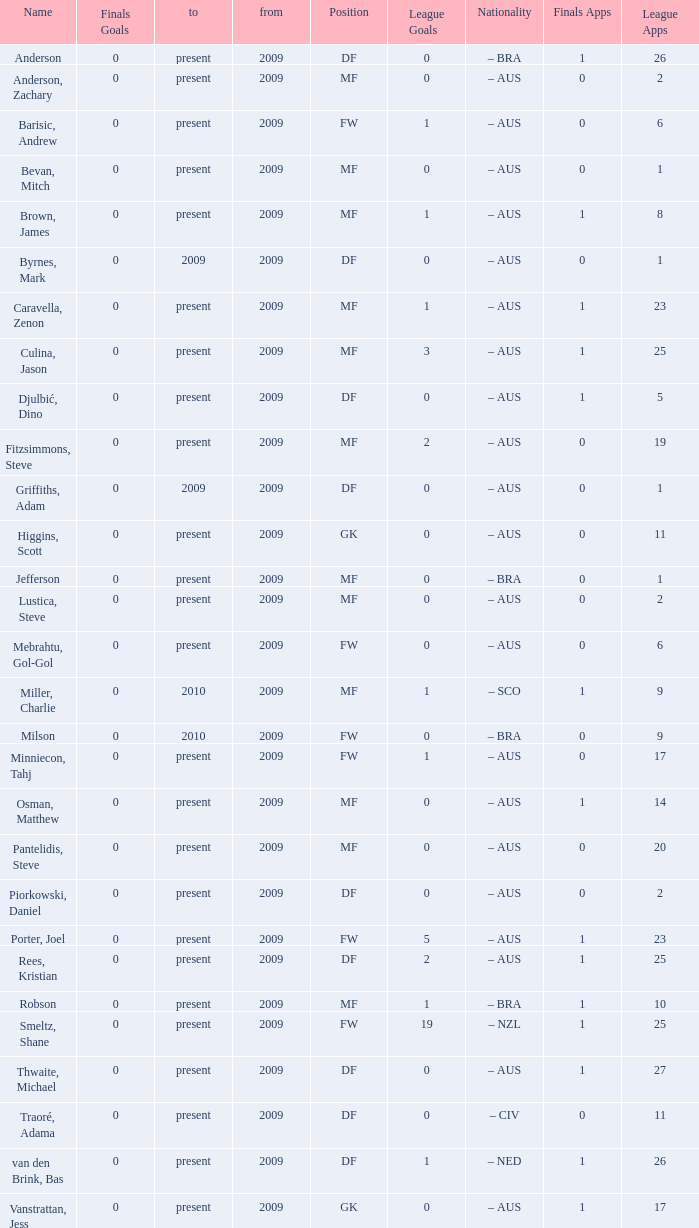Would you mind parsing the complete table? {'header': ['Name', 'Finals Goals', 'to', 'from', 'Position', 'League Goals', 'Nationality', 'Finals Apps', 'League Apps'], 'rows': [['Anderson', '0', 'present', '2009', 'DF', '0', '– BRA', '1', '26'], ['Anderson, Zachary', '0', 'present', '2009', 'MF', '0', '– AUS', '0', '2'], ['Barisic, Andrew', '0', 'present', '2009', 'FW', '1', '– AUS', '0', '6'], ['Bevan, Mitch', '0', 'present', '2009', 'MF', '0', '– AUS', '0', '1'], ['Brown, James', '0', 'present', '2009', 'MF', '1', '– AUS', '1', '8'], ['Byrnes, Mark', '0', '2009', '2009', 'DF', '0', '– AUS', '0', '1'], ['Caravella, Zenon', '0', 'present', '2009', 'MF', '1', '– AUS', '1', '23'], ['Culina, Jason', '0', 'present', '2009', 'MF', '3', '– AUS', '1', '25'], ['Djulbić, Dino', '0', 'present', '2009', 'DF', '0', '– AUS', '1', '5'], ['Fitzsimmons, Steve', '0', 'present', '2009', 'MF', '2', '– AUS', '0', '19'], ['Griffiths, Adam', '0', '2009', '2009', 'DF', '0', '– AUS', '0', '1'], ['Higgins, Scott', '0', 'present', '2009', 'GK', '0', '– AUS', '0', '11'], ['Jefferson', '0', 'present', '2009', 'MF', '0', '– BRA', '0', '1'], ['Lustica, Steve', '0', 'present', '2009', 'MF', '0', '– AUS', '0', '2'], ['Mebrahtu, Gol-Gol', '0', 'present', '2009', 'FW', '0', '– AUS', '0', '6'], ['Miller, Charlie', '0', '2010', '2009', 'MF', '1', '– SCO', '1', '9'], ['Milson', '0', '2010', '2009', 'FW', '0', '– BRA', '0', '9'], ['Minniecon, Tahj', '0', 'present', '2009', 'FW', '1', '– AUS', '0', '17'], ['Osman, Matthew', '0', 'present', '2009', 'MF', '0', '– AUS', '1', '14'], ['Pantelidis, Steve', '0', 'present', '2009', 'MF', '0', '– AUS', '0', '20'], ['Piorkowski, Daniel', '0', 'present', '2009', 'DF', '0', '– AUS', '0', '2'], ['Porter, Joel', '0', 'present', '2009', 'FW', '5', '– AUS', '1', '23'], ['Rees, Kristian', '0', 'present', '2009', 'DF', '2', '– AUS', '1', '25'], ['Robson', '0', 'present', '2009', 'MF', '1', '– BRA', '1', '10'], ['Smeltz, Shane', '0', 'present', '2009', 'FW', '19', '– NZL', '1', '25'], ['Thwaite, Michael', '0', 'present', '2009', 'DF', '0', '– AUS', '1', '27'], ['Traoré, Adama', '0', 'present', '2009', 'DF', '0', '– CIV', '0', '11'], ['van den Brink, Bas', '0', 'present', '2009', 'DF', '1', '– NED', '1', '26'], ['Vanstrattan, Jess', '0', 'present', '2009', 'GK', '0', '– AUS', '1', '17']]} Name the position for van den brink, bas DF. 